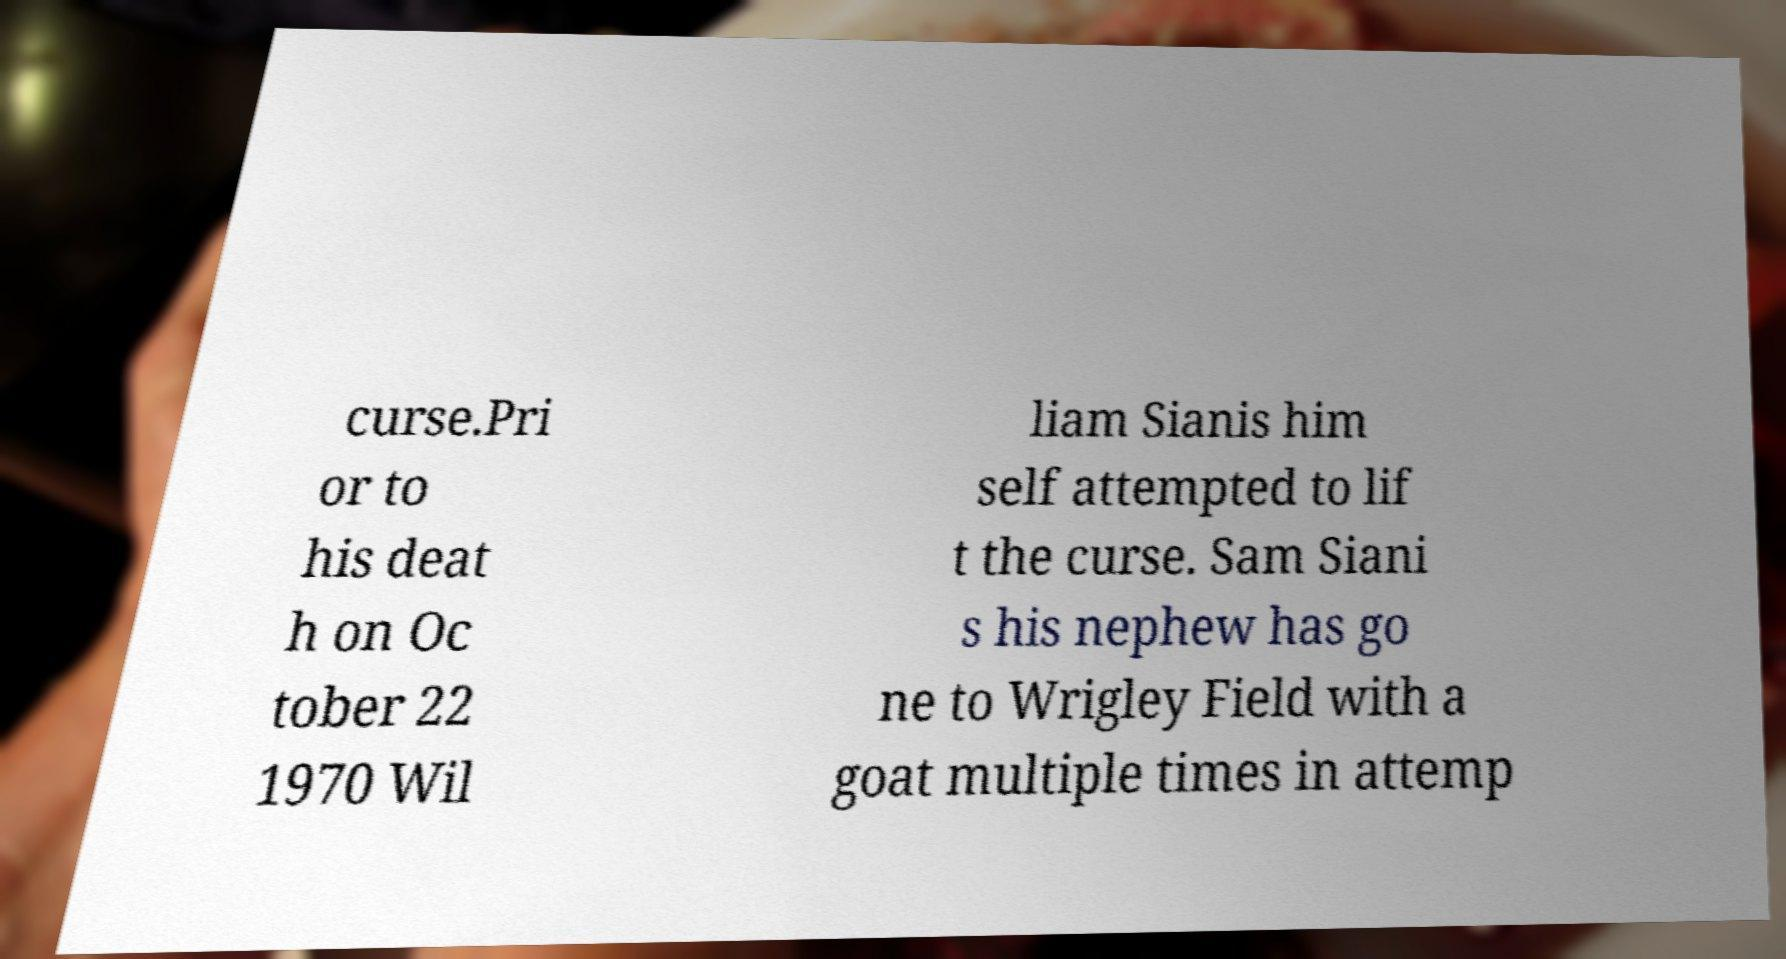Could you extract and type out the text from this image? curse.Pri or to his deat h on Oc tober 22 1970 Wil liam Sianis him self attempted to lif t the curse. Sam Siani s his nephew has go ne to Wrigley Field with a goat multiple times in attemp 